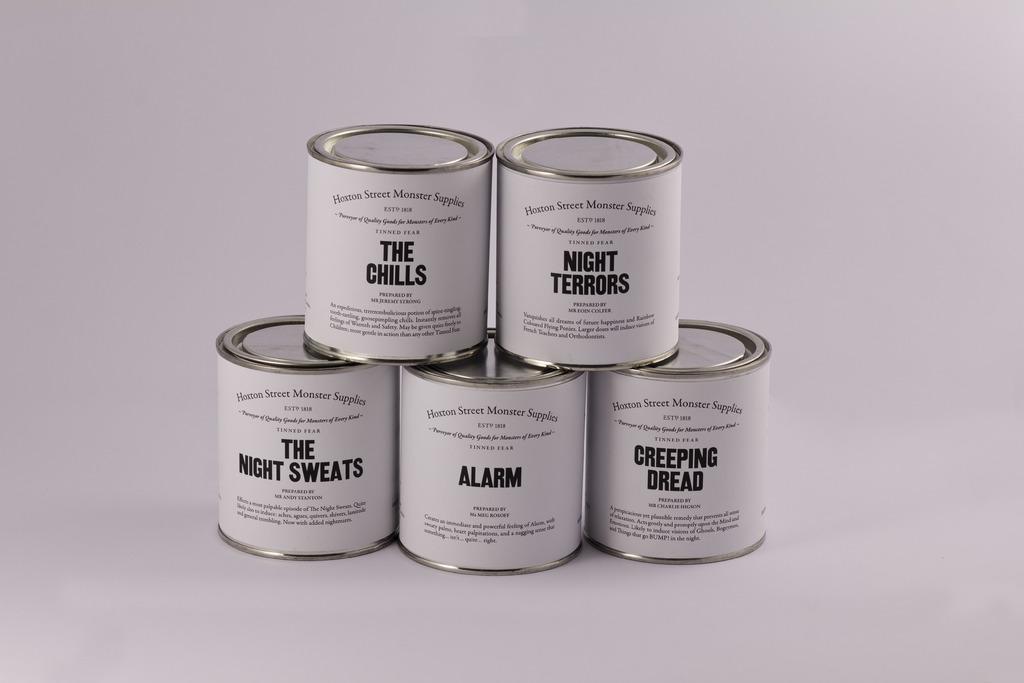Could you give a brief overview of what you see in this image? In this image we can see things placed in the rows. 